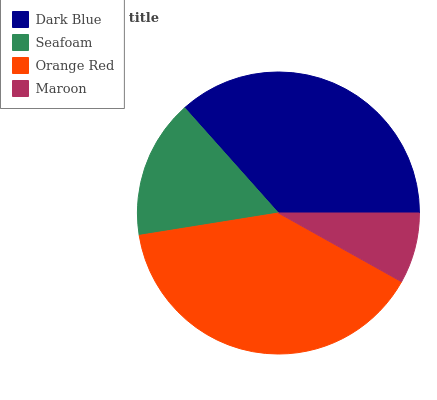Is Maroon the minimum?
Answer yes or no. Yes. Is Orange Red the maximum?
Answer yes or no. Yes. Is Seafoam the minimum?
Answer yes or no. No. Is Seafoam the maximum?
Answer yes or no. No. Is Dark Blue greater than Seafoam?
Answer yes or no. Yes. Is Seafoam less than Dark Blue?
Answer yes or no. Yes. Is Seafoam greater than Dark Blue?
Answer yes or no. No. Is Dark Blue less than Seafoam?
Answer yes or no. No. Is Dark Blue the high median?
Answer yes or no. Yes. Is Seafoam the low median?
Answer yes or no. Yes. Is Seafoam the high median?
Answer yes or no. No. Is Maroon the low median?
Answer yes or no. No. 